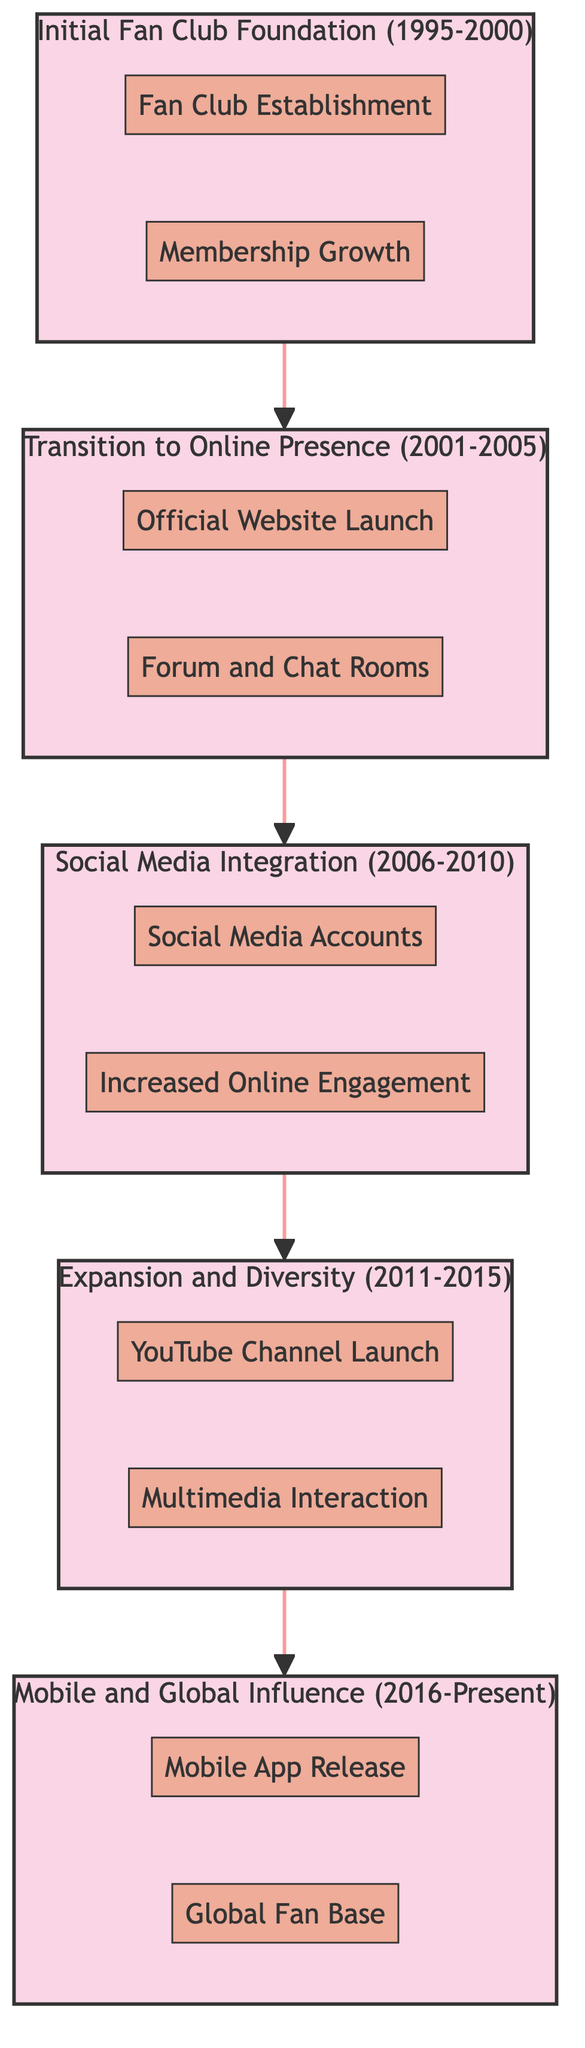What is the time period for the "Initial Fan Club Foundation"? The block labeled "Initial Fan Club Foundation" clearly states its time period as "1995-2000."
Answer: 1995-2000 How many elements are in the "Social Media Integration" block? In the "Social Media Integration" block, there are two elements listed: "Social Media Accounts" and "Increased Online Engagement." Therefore, the total count is two.
Answer: 2 What element was introduced in the period "2011-2015"? In the block for "Expansion and Diversity," the elements introduced during this time are "YouTube Channel Launch" and "Multimedia Interaction." Since the question focuses on one element, "YouTube Channel Launch" is an example from that period.
Answer: YouTube Channel Launch What connects the "Transition to Online Presence" and "Social Media Integration" blocks? The arrow direction from "Transition to Online Presence" to "Social Media Integration" indicates a sequential connection, reflecting the progression of Myraida Chaves' fan club's evolution from an online presence to social media engagement.
Answer: Social Media Integration What type of media interaction was started in the "Expansion and Diversity" block? The "Expansion and Diversity" block lists "Multimedia Interaction," which specifically refers to the diversification into video updates, live streaming events, and podcasts.
Answer: Multimedia Interaction Which block includes the "Mobile App Release"? The "Mobile and Global Influence" block includes the element "Mobile App Release," indicating its introduction during that time period from 2016 to Present.
Answer: Mobile and Global Influence Which two social media platforms are mentioned in the "Social Media Integration" block? The "Social Media Integration" block mentions "Facebook" and "Twitter" as the official social media profiles created during that period. Thus, these are the platforms referenced.
Answer: Facebook and Twitter What was the first significant expansion after the initial fan club foundation? The first significant expansion was marked by the launch of the "Official Website" in the "Transition to Online Presence" block, indicating the move towards online engagement after the fan club's foundation.
Answer: Official Website Launch 